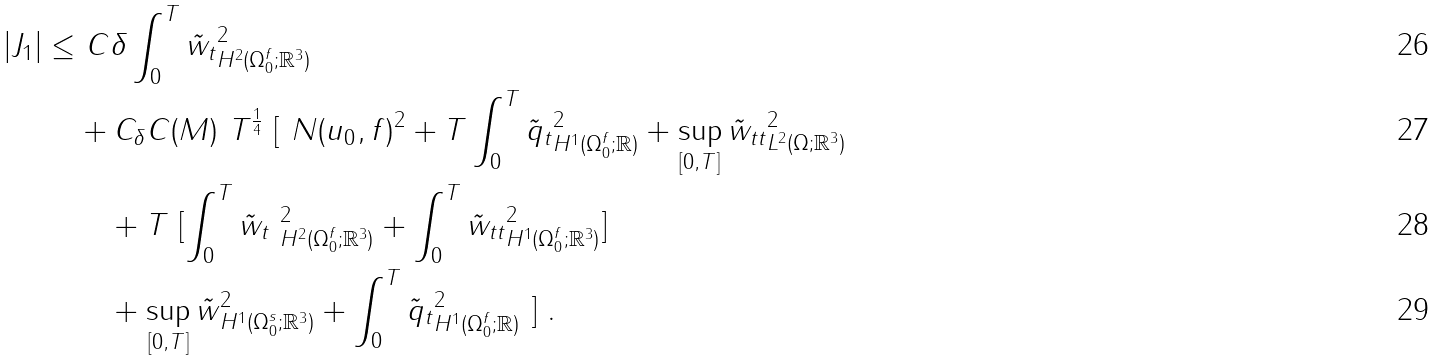<formula> <loc_0><loc_0><loc_500><loc_500>| J _ { 1 } | \leq & \ C \delta \int _ { 0 } ^ { T } \| \tilde { w } _ { t } \| ^ { 2 } _ { H ^ { 2 } ( \Omega _ { 0 } ^ { f } ; { \mathbb { R } } ^ { 3 } ) } \\ & + C _ { \delta } C ( M ) \ T ^ { \frac { 1 } { 4 } } \ [ \ N ( u _ { 0 } , f ) ^ { 2 } + T \int _ { 0 } ^ { T } \| \tilde { q } _ { t } \| ^ { 2 } _ { H ^ { 1 } ( \Omega _ { 0 } ^ { f } ; { \mathbb { R } } ) } + \sup _ { [ 0 , T ] } \| \tilde { w } _ { t t } \| ^ { 2 } _ { L ^ { 2 } ( \Omega ; { \mathbb { R } } ^ { 3 } ) } \\ & \quad + T \ [ \int _ { 0 } ^ { T } \| \tilde { w } _ { t } \ \| ^ { 2 } _ { H ^ { 2 } ( \Omega _ { 0 } ^ { f } ; { \mathbb { R } } ^ { 3 } ) } + \int _ { 0 } ^ { T } \| \tilde { w } _ { t t } \| ^ { 2 } _ { H ^ { 1 } ( \Omega _ { 0 } ^ { f } ; { \mathbb { R } } ^ { 3 } ) } ] \\ & \quad + \sup _ { [ 0 , T ] } \| \tilde { w } \| ^ { 2 } _ { H ^ { 1 } ( \Omega _ { 0 } ^ { s } ; { \mathbb { R } } ^ { 3 } ) } + \int _ { 0 } ^ { T } \| \tilde { q } _ { t } \| ^ { 2 } _ { H ^ { 1 } ( \Omega _ { 0 } ^ { f } ; { \mathbb { R } } ) } \ ] \ .</formula> 